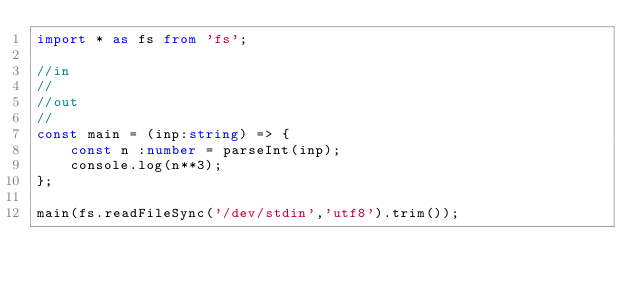Convert code to text. <code><loc_0><loc_0><loc_500><loc_500><_TypeScript_>import * as fs from 'fs';

//in
//
//out
//
const main = (inp:string) => {
    const n :number = parseInt(inp);
    console.log(n**3);
};

main(fs.readFileSync('/dev/stdin','utf8').trim());</code> 